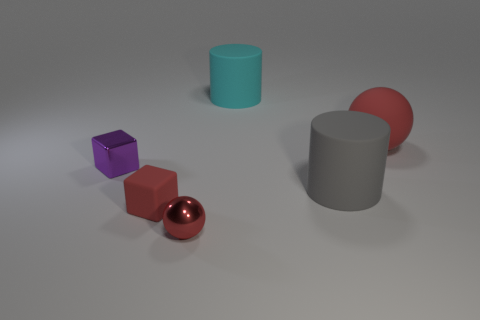What number of large spheres are the same color as the small matte block?
Offer a terse response. 1. How big is the red thing that is behind the tiny red shiny object and left of the big gray thing?
Offer a terse response. Small. Is the number of tiny red matte objects that are left of the small matte object less than the number of large cyan rubber cylinders?
Your answer should be very brief. Yes. Do the large cyan object and the tiny purple cube have the same material?
Your response must be concise. No. What number of things are either cyan rubber objects or small brown cubes?
Ensure brevity in your answer.  1. How many large cyan objects are the same material as the small purple cube?
Your response must be concise. 0. There is a shiny object that is the same shape as the tiny rubber thing; what size is it?
Your answer should be compact. Small. There is a red matte cube; are there any red balls in front of it?
Your answer should be very brief. Yes. What material is the big cyan object?
Ensure brevity in your answer.  Rubber. Do the ball that is left of the large red thing and the big sphere have the same color?
Your answer should be very brief. Yes. 